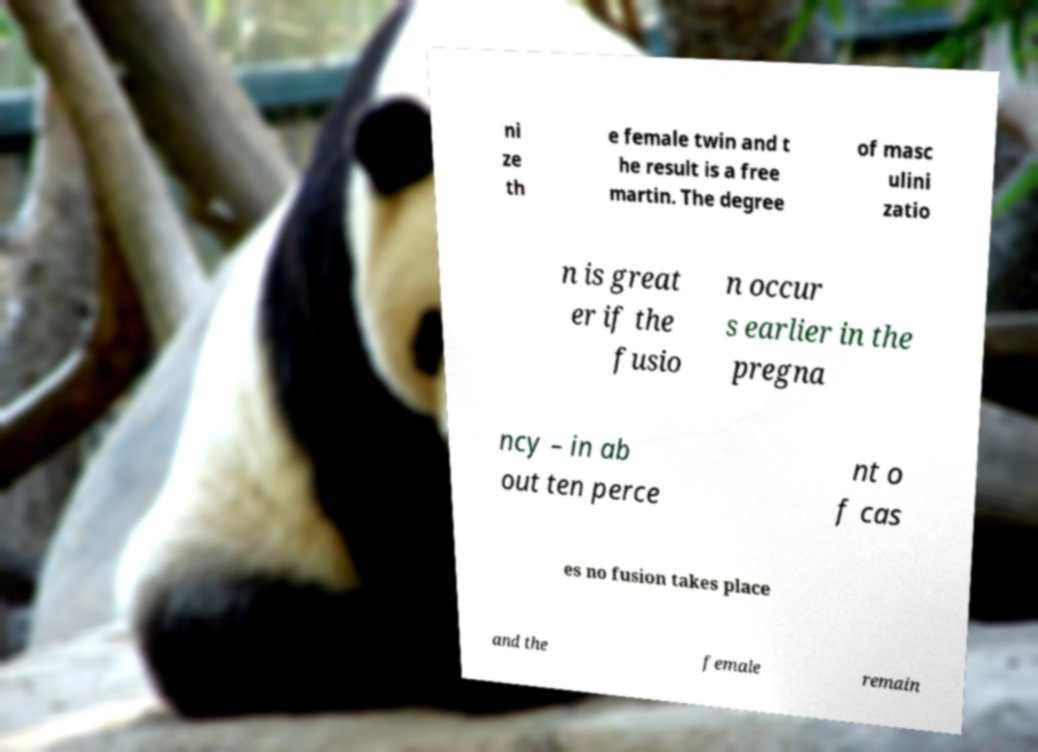Can you read and provide the text displayed in the image?This photo seems to have some interesting text. Can you extract and type it out for me? ni ze th e female twin and t he result is a free martin. The degree of masc ulini zatio n is great er if the fusio n occur s earlier in the pregna ncy – in ab out ten perce nt o f cas es no fusion takes place and the female remain 